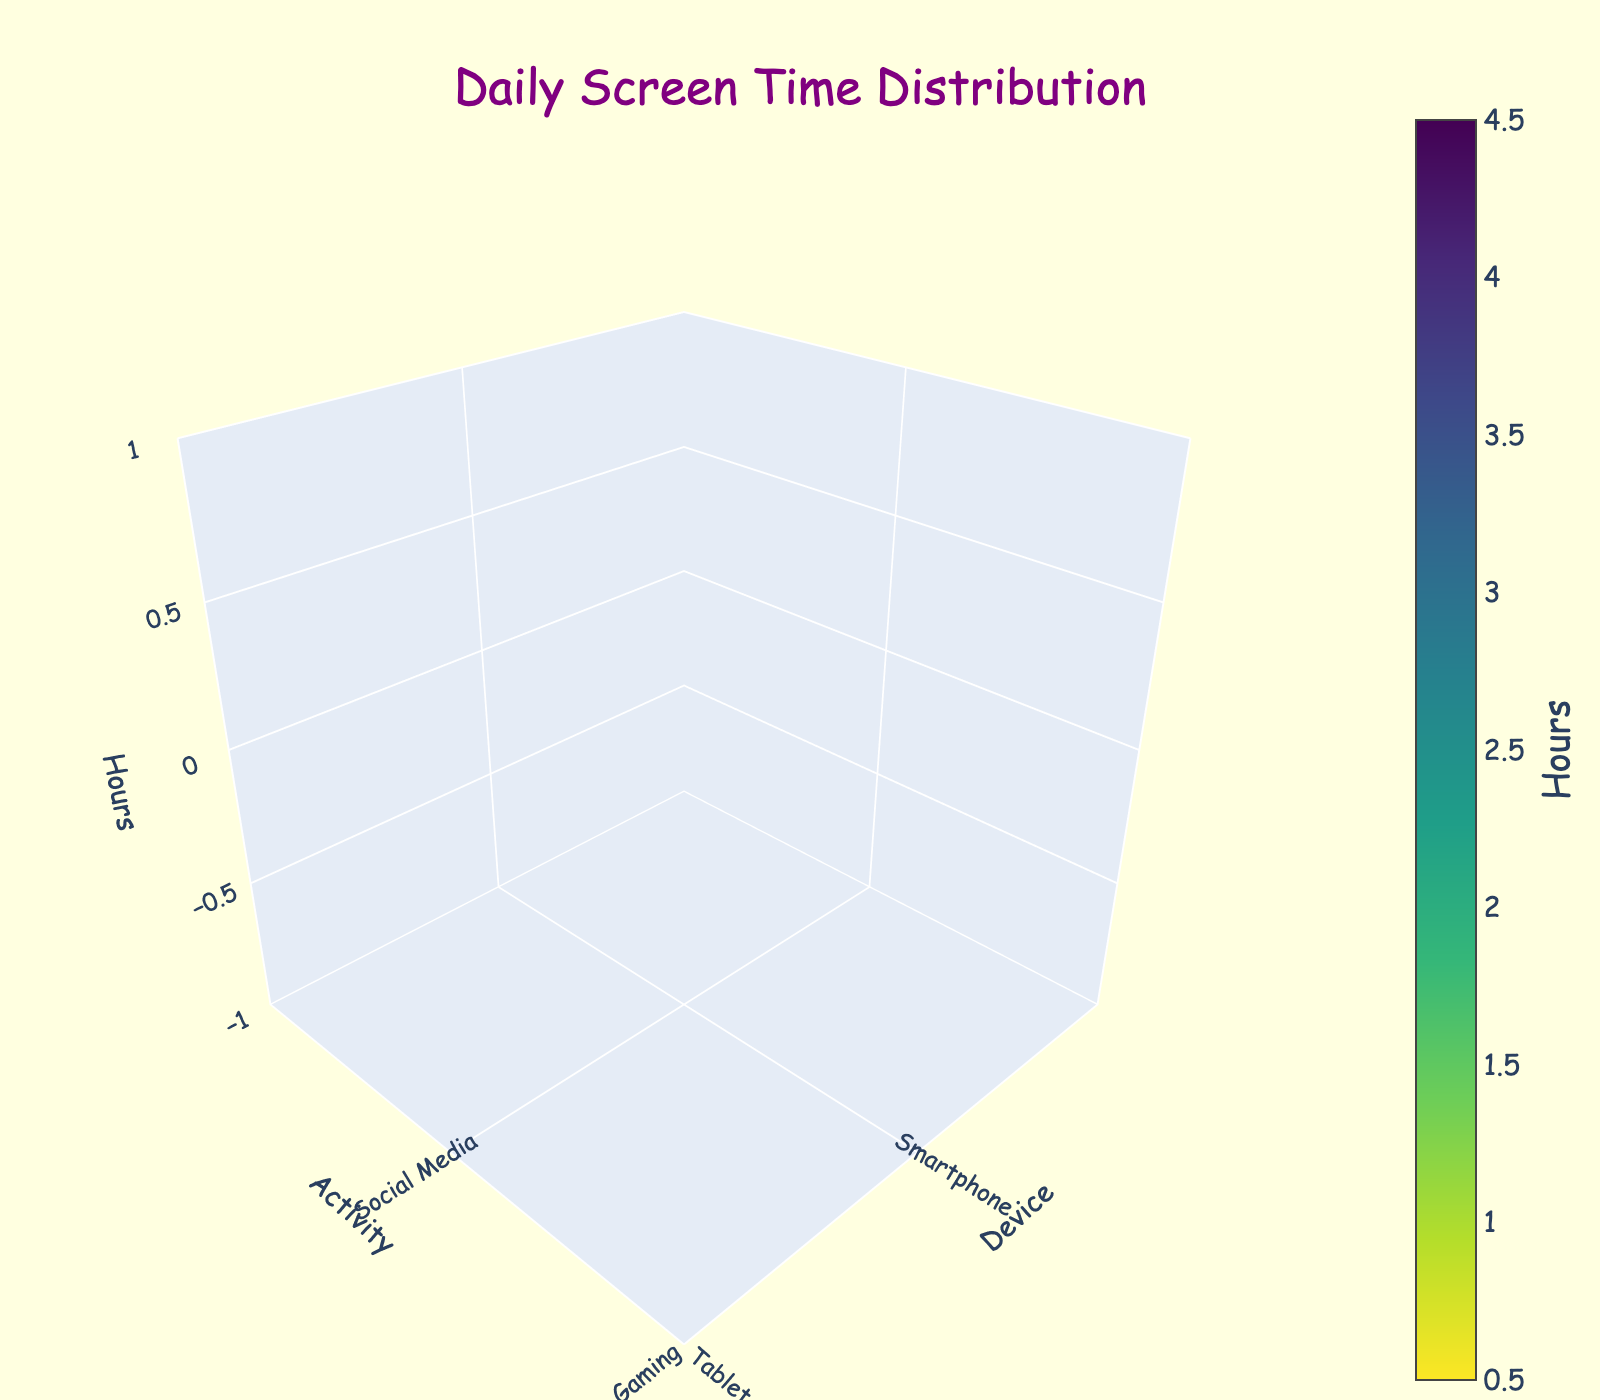What's the title of the figure? The title is typically located at the top and should be evident in the plot.
Answer: Daily Screen Time Distribution Which device has the highest number of gaming hours? Look at the sections representing "Gaming" activities and compare the hours for each device.
Answer: Game Console How many hours are spent on streaming videos using TV and Tablet combined? Identify the hours for "Streaming Videos" on both TV and Tablet and sum them up: 2.5 (TV) + 2.0 (Tablet).
Answer: 4.5 Which device is used the most for social media? Identify the device with the highest hours in the "Social Media" activity category.
Answer: Smartphone Compare the screen time spent on gaming between the Computer and Smartphone. Look at the hours for the "Gaming" activity on both Computer and Smartphone and compare them: 3.0 (Computer) vs 2.0 (Smartphone).
Answer: Computer What's the total screen time spent using the Computer? Sum all hours spent on different activities using the Computer: 3.0 (Gaming) + 1.0 (Streaming Videos) + 0.5 (Homework).
Answer: 4.5 Which device is used the least? Identify the device with the lowest sum of hours across all activities, in this case, the Tablet is the only device with a value (0.5) that stands out compared to all other device's total hours.
Answer: Tablet Which activity is more popular on a Smartphone: Gaming or Streaming Videos? Compare the hours spent on "Gaming" and "Streaming Videos" using a Smartphone: 2.0 (Gaming) vs 1.5 (Streaming Videos).
Answer: Gaming How many devices are shown in the figure? Count the unique devices listed in the data, which include Smartphone, Tablet, Computer, TV, and Game Console.
Answer: 5 What's the average screen time for gaming across all devices? Calculate the mean of gaming hours for Smartphone (2.0), Tablet (1.5), Computer (3.0), TV (1.0), and Game Console (3.5). Add them up and divide by the number of devices: (2.0 + 1.5 + 3.0 + 1.0 + 3.5) / 5.
Answer: 2.2 